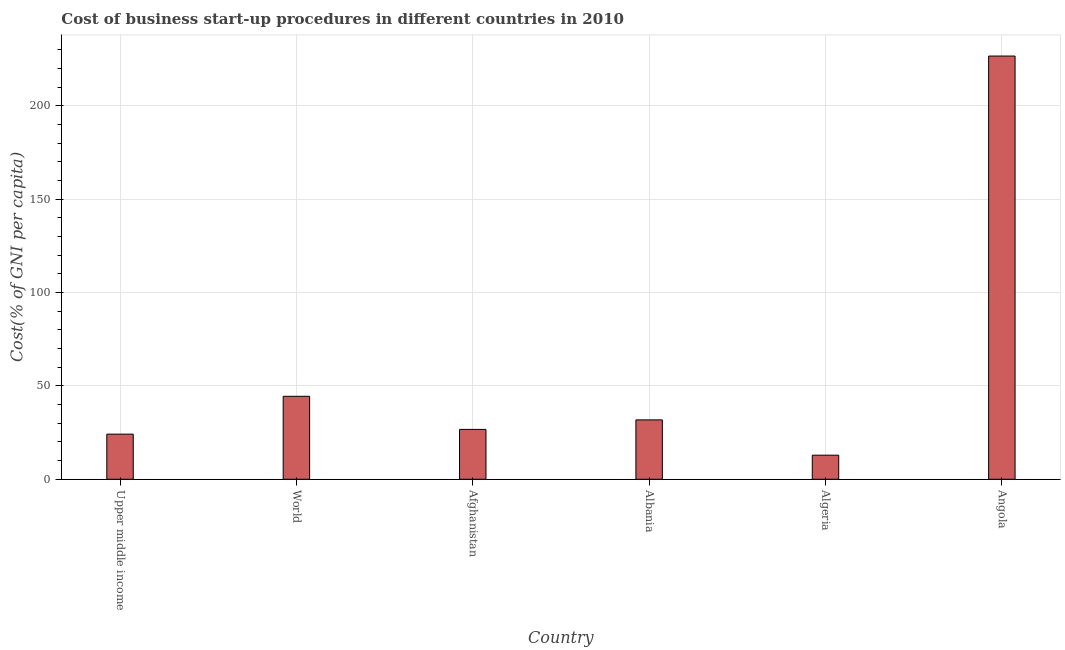Does the graph contain any zero values?
Offer a very short reply. No. Does the graph contain grids?
Ensure brevity in your answer.  Yes. What is the title of the graph?
Provide a short and direct response. Cost of business start-up procedures in different countries in 2010. What is the label or title of the X-axis?
Your answer should be compact. Country. What is the label or title of the Y-axis?
Your answer should be compact. Cost(% of GNI per capita). What is the cost of business startup procedures in Algeria?
Ensure brevity in your answer.  12.9. Across all countries, what is the maximum cost of business startup procedures?
Provide a succinct answer. 226.6. In which country was the cost of business startup procedures maximum?
Provide a succinct answer. Angola. In which country was the cost of business startup procedures minimum?
Make the answer very short. Algeria. What is the sum of the cost of business startup procedures?
Give a very brief answer. 366.58. What is the difference between the cost of business startup procedures in Afghanistan and Upper middle income?
Provide a succinct answer. 2.54. What is the average cost of business startup procedures per country?
Provide a succinct answer. 61.1. What is the median cost of business startup procedures?
Offer a very short reply. 29.25. In how many countries, is the cost of business startup procedures greater than 120 %?
Offer a terse response. 1. What is the ratio of the cost of business startup procedures in Algeria to that in World?
Give a very brief answer. 0.29. Is the cost of business startup procedures in Afghanistan less than that in Algeria?
Make the answer very short. No. What is the difference between the highest and the second highest cost of business startup procedures?
Provide a short and direct response. 182.18. Is the sum of the cost of business startup procedures in Afghanistan and World greater than the maximum cost of business startup procedures across all countries?
Offer a terse response. No. What is the difference between the highest and the lowest cost of business startup procedures?
Offer a terse response. 213.7. In how many countries, is the cost of business startup procedures greater than the average cost of business startup procedures taken over all countries?
Your response must be concise. 1. How many bars are there?
Provide a short and direct response. 6. Are all the bars in the graph horizontal?
Keep it short and to the point. No. How many countries are there in the graph?
Provide a short and direct response. 6. What is the difference between two consecutive major ticks on the Y-axis?
Provide a short and direct response. 50. What is the Cost(% of GNI per capita) of Upper middle income?
Ensure brevity in your answer.  24.16. What is the Cost(% of GNI per capita) of World?
Your answer should be very brief. 44.42. What is the Cost(% of GNI per capita) of Afghanistan?
Give a very brief answer. 26.7. What is the Cost(% of GNI per capita) of Albania?
Offer a terse response. 31.8. What is the Cost(% of GNI per capita) in Algeria?
Offer a very short reply. 12.9. What is the Cost(% of GNI per capita) of Angola?
Your answer should be compact. 226.6. What is the difference between the Cost(% of GNI per capita) in Upper middle income and World?
Offer a terse response. -20.26. What is the difference between the Cost(% of GNI per capita) in Upper middle income and Afghanistan?
Ensure brevity in your answer.  -2.54. What is the difference between the Cost(% of GNI per capita) in Upper middle income and Albania?
Provide a succinct answer. -7.64. What is the difference between the Cost(% of GNI per capita) in Upper middle income and Algeria?
Provide a short and direct response. 11.26. What is the difference between the Cost(% of GNI per capita) in Upper middle income and Angola?
Make the answer very short. -202.44. What is the difference between the Cost(% of GNI per capita) in World and Afghanistan?
Offer a very short reply. 17.72. What is the difference between the Cost(% of GNI per capita) in World and Albania?
Ensure brevity in your answer.  12.62. What is the difference between the Cost(% of GNI per capita) in World and Algeria?
Give a very brief answer. 31.52. What is the difference between the Cost(% of GNI per capita) in World and Angola?
Provide a succinct answer. -182.18. What is the difference between the Cost(% of GNI per capita) in Afghanistan and Albania?
Your response must be concise. -5.1. What is the difference between the Cost(% of GNI per capita) in Afghanistan and Angola?
Your answer should be compact. -199.9. What is the difference between the Cost(% of GNI per capita) in Albania and Angola?
Provide a succinct answer. -194.8. What is the difference between the Cost(% of GNI per capita) in Algeria and Angola?
Give a very brief answer. -213.7. What is the ratio of the Cost(% of GNI per capita) in Upper middle income to that in World?
Give a very brief answer. 0.54. What is the ratio of the Cost(% of GNI per capita) in Upper middle income to that in Afghanistan?
Give a very brief answer. 0.91. What is the ratio of the Cost(% of GNI per capita) in Upper middle income to that in Albania?
Keep it short and to the point. 0.76. What is the ratio of the Cost(% of GNI per capita) in Upper middle income to that in Algeria?
Ensure brevity in your answer.  1.87. What is the ratio of the Cost(% of GNI per capita) in Upper middle income to that in Angola?
Offer a very short reply. 0.11. What is the ratio of the Cost(% of GNI per capita) in World to that in Afghanistan?
Offer a very short reply. 1.66. What is the ratio of the Cost(% of GNI per capita) in World to that in Albania?
Keep it short and to the point. 1.4. What is the ratio of the Cost(% of GNI per capita) in World to that in Algeria?
Offer a very short reply. 3.44. What is the ratio of the Cost(% of GNI per capita) in World to that in Angola?
Make the answer very short. 0.2. What is the ratio of the Cost(% of GNI per capita) in Afghanistan to that in Albania?
Provide a short and direct response. 0.84. What is the ratio of the Cost(% of GNI per capita) in Afghanistan to that in Algeria?
Provide a succinct answer. 2.07. What is the ratio of the Cost(% of GNI per capita) in Afghanistan to that in Angola?
Provide a short and direct response. 0.12. What is the ratio of the Cost(% of GNI per capita) in Albania to that in Algeria?
Ensure brevity in your answer.  2.46. What is the ratio of the Cost(% of GNI per capita) in Albania to that in Angola?
Provide a succinct answer. 0.14. What is the ratio of the Cost(% of GNI per capita) in Algeria to that in Angola?
Offer a very short reply. 0.06. 